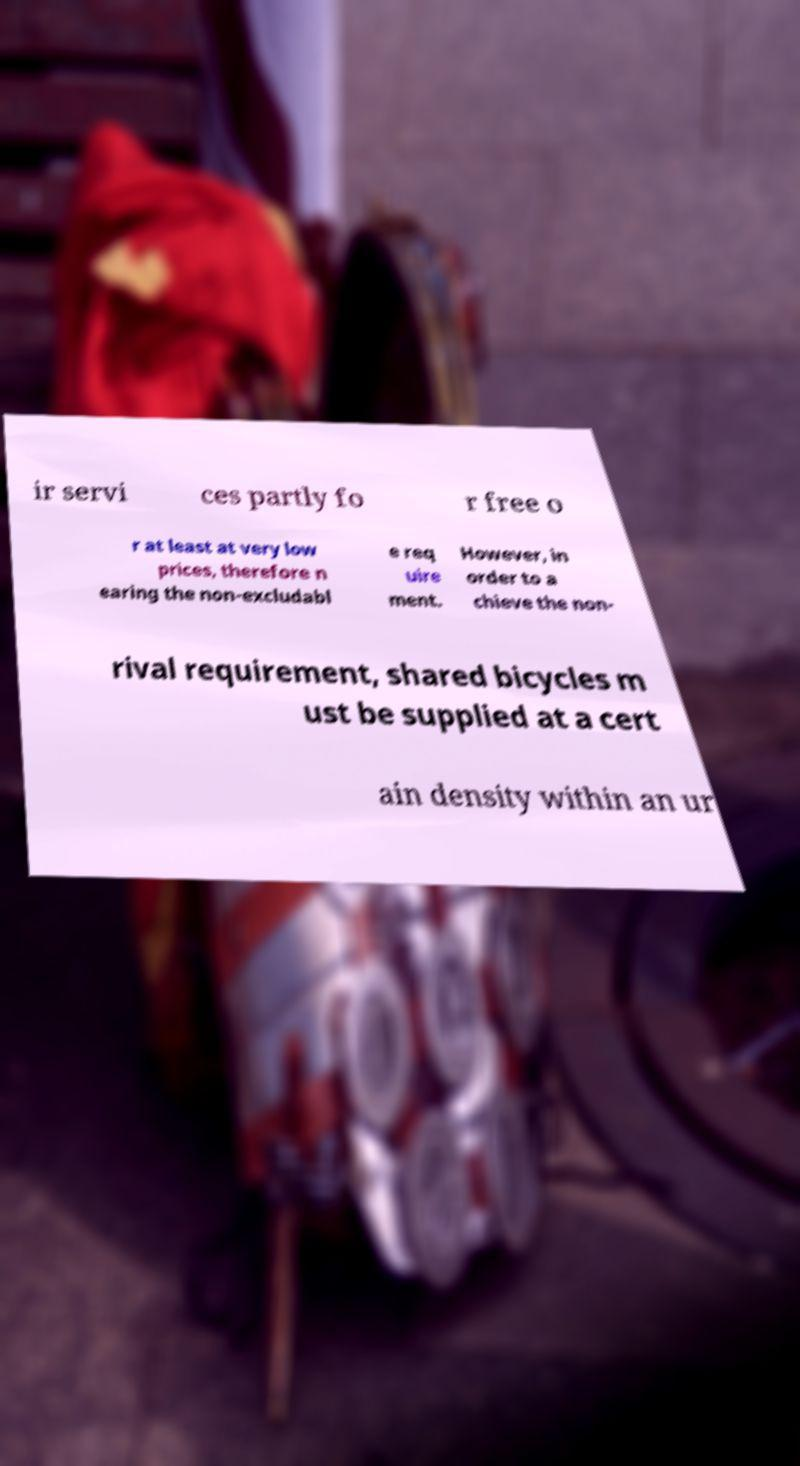For documentation purposes, I need the text within this image transcribed. Could you provide that? ir servi ces partly fo r free o r at least at very low prices, therefore n earing the non-excludabl e req uire ment. However, in order to a chieve the non- rival requirement, shared bicycles m ust be supplied at a cert ain density within an ur 